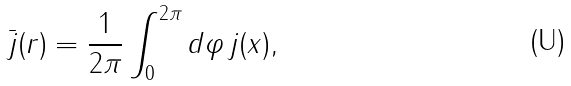<formula> <loc_0><loc_0><loc_500><loc_500>\bar { j } ( r ) = \frac { 1 } { 2 \pi } \int _ { 0 } ^ { 2 \pi } d \varphi \, j ( x ) ,</formula> 